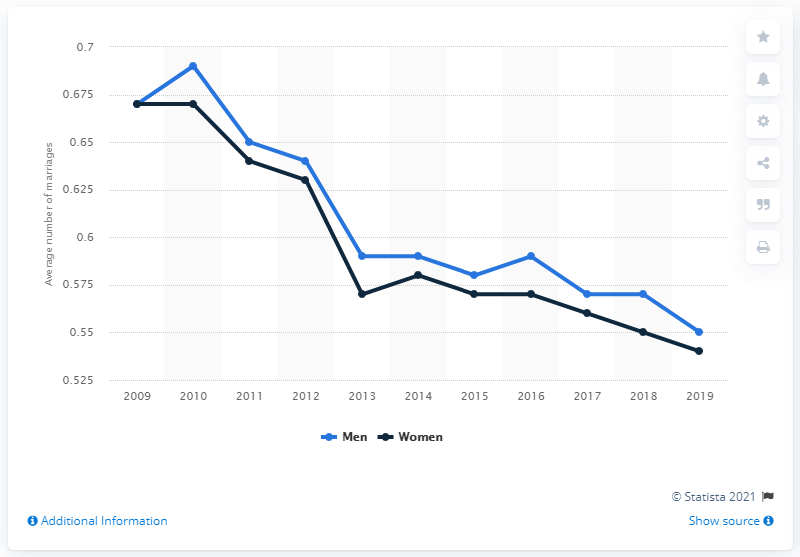Specify some key components in this picture. The average number of marriages has declined since 2010. 